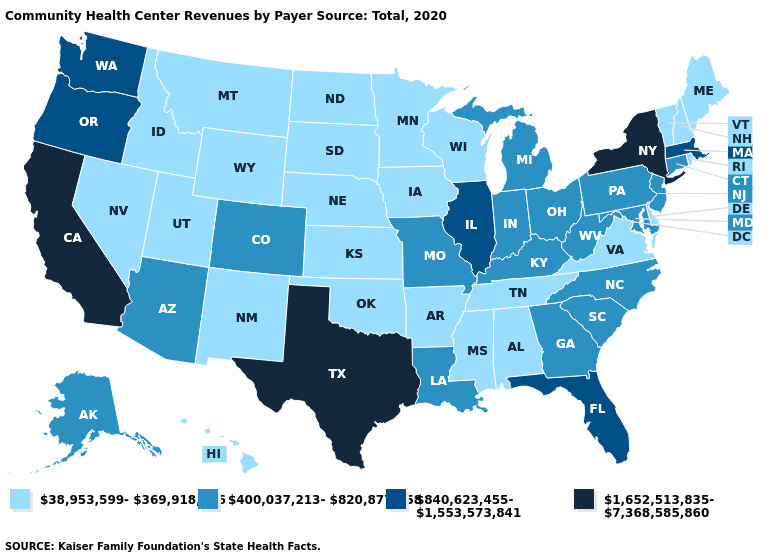What is the value of Wyoming?
Keep it brief. 38,953,599-369,918,456. Name the states that have a value in the range 38,953,599-369,918,456?
Be succinct. Alabama, Arkansas, Delaware, Hawaii, Idaho, Iowa, Kansas, Maine, Minnesota, Mississippi, Montana, Nebraska, Nevada, New Hampshire, New Mexico, North Dakota, Oklahoma, Rhode Island, South Dakota, Tennessee, Utah, Vermont, Virginia, Wisconsin, Wyoming. Does Texas have a lower value than Nevada?
Be succinct. No. Name the states that have a value in the range 840,623,455-1,553,573,841?
Quick response, please. Florida, Illinois, Massachusetts, Oregon, Washington. Does Texas have the same value as Tennessee?
Concise answer only. No. What is the highest value in states that border Georgia?
Give a very brief answer. 840,623,455-1,553,573,841. What is the lowest value in the MidWest?
Give a very brief answer. 38,953,599-369,918,456. Among the states that border Florida , does Alabama have the lowest value?
Give a very brief answer. Yes. Does New York have the highest value in the USA?
Write a very short answer. Yes. What is the value of Arizona?
Quick response, please. 400,037,213-820,877,658. What is the value of Kentucky?
Short answer required. 400,037,213-820,877,658. What is the value of North Dakota?
Short answer required. 38,953,599-369,918,456. Does Arkansas have the highest value in the USA?
Give a very brief answer. No. What is the value of Rhode Island?
Write a very short answer. 38,953,599-369,918,456. 